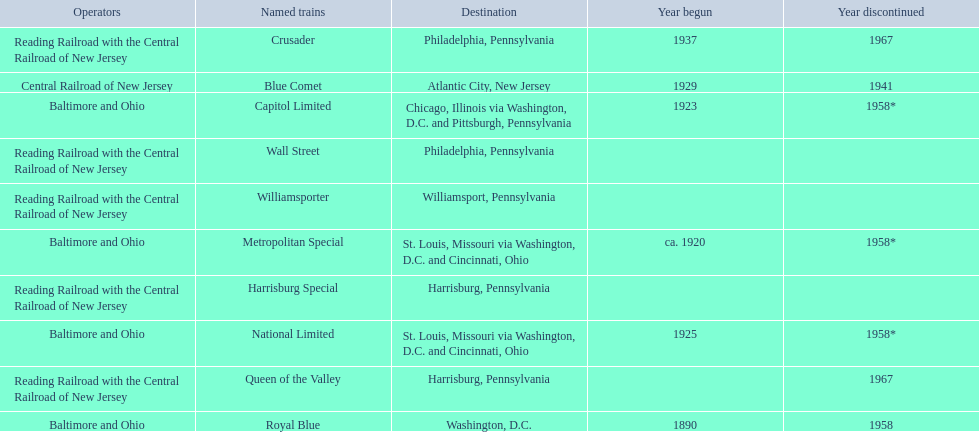What destinations are there? Chicago, Illinois via Washington, D.C. and Pittsburgh, Pennsylvania, St. Louis, Missouri via Washington, D.C. and Cincinnati, Ohio, St. Louis, Missouri via Washington, D.C. and Cincinnati, Ohio, Washington, D.C., Atlantic City, New Jersey, Philadelphia, Pennsylvania, Harrisburg, Pennsylvania, Harrisburg, Pennsylvania, Philadelphia, Pennsylvania, Williamsport, Pennsylvania. Which one is at the top of the list? Chicago, Illinois via Washington, D.C. and Pittsburgh, Pennsylvania. 